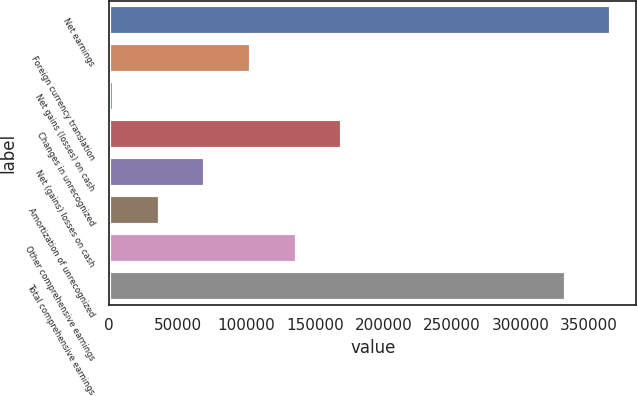Convert chart. <chart><loc_0><loc_0><loc_500><loc_500><bar_chart><fcel>Net earnings<fcel>Foreign currency translation<fcel>Net gains (losses) on cash<fcel>Changes in unrecognized<fcel>Net (gains) losses on cash<fcel>Amortization of unrecognized<fcel>Other comprehensive earnings<fcel>Total comprehensive earnings<nl><fcel>366094<fcel>103392<fcel>3704<fcel>169852<fcel>70163<fcel>36933.5<fcel>136622<fcel>332864<nl></chart> 